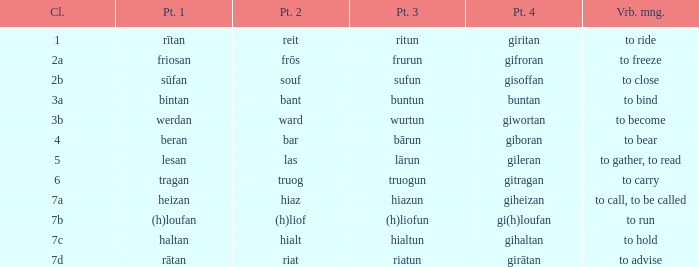What is the verb meaning of the word with part 2 "bant"? To bind. 